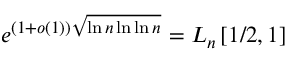<formula> <loc_0><loc_0><loc_500><loc_500>e ^ { ( 1 + o ( 1 ) ) { \sqrt { \ln n \ln \ln n } } } = L _ { n } \left [ 1 / 2 , 1 \right ]</formula> 